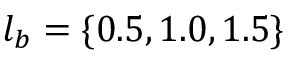<formula> <loc_0><loc_0><loc_500><loc_500>l _ { b } = \{ 0 . 5 , 1 . 0 , 1 . 5 \}</formula> 